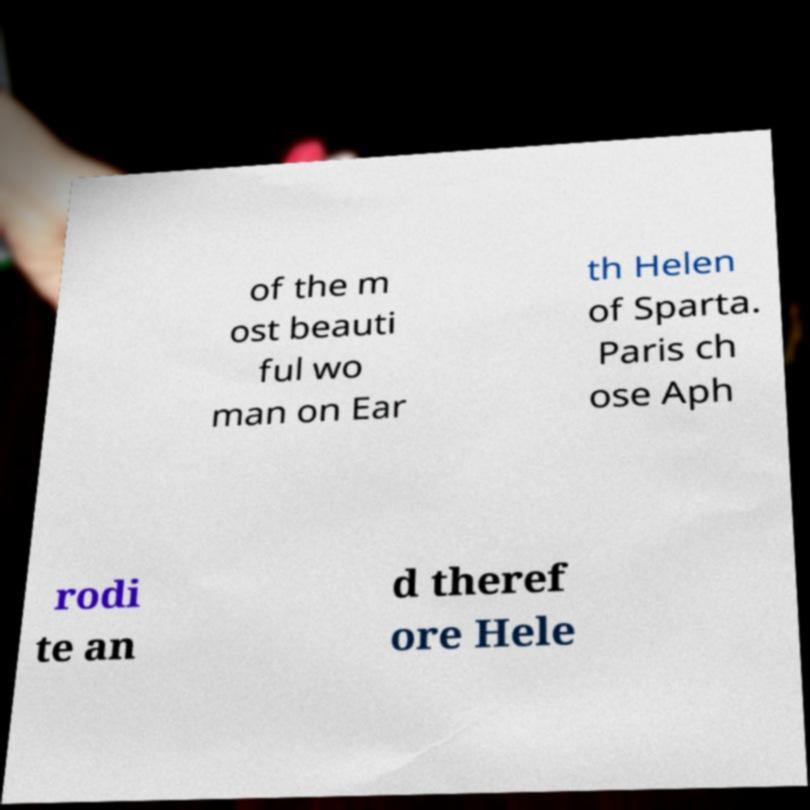Can you accurately transcribe the text from the provided image for me? of the m ost beauti ful wo man on Ear th Helen of Sparta. Paris ch ose Aph rodi te an d theref ore Hele 